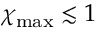Convert formula to latex. <formula><loc_0><loc_0><loc_500><loc_500>\chi _ { \max } \lesssim 1</formula> 